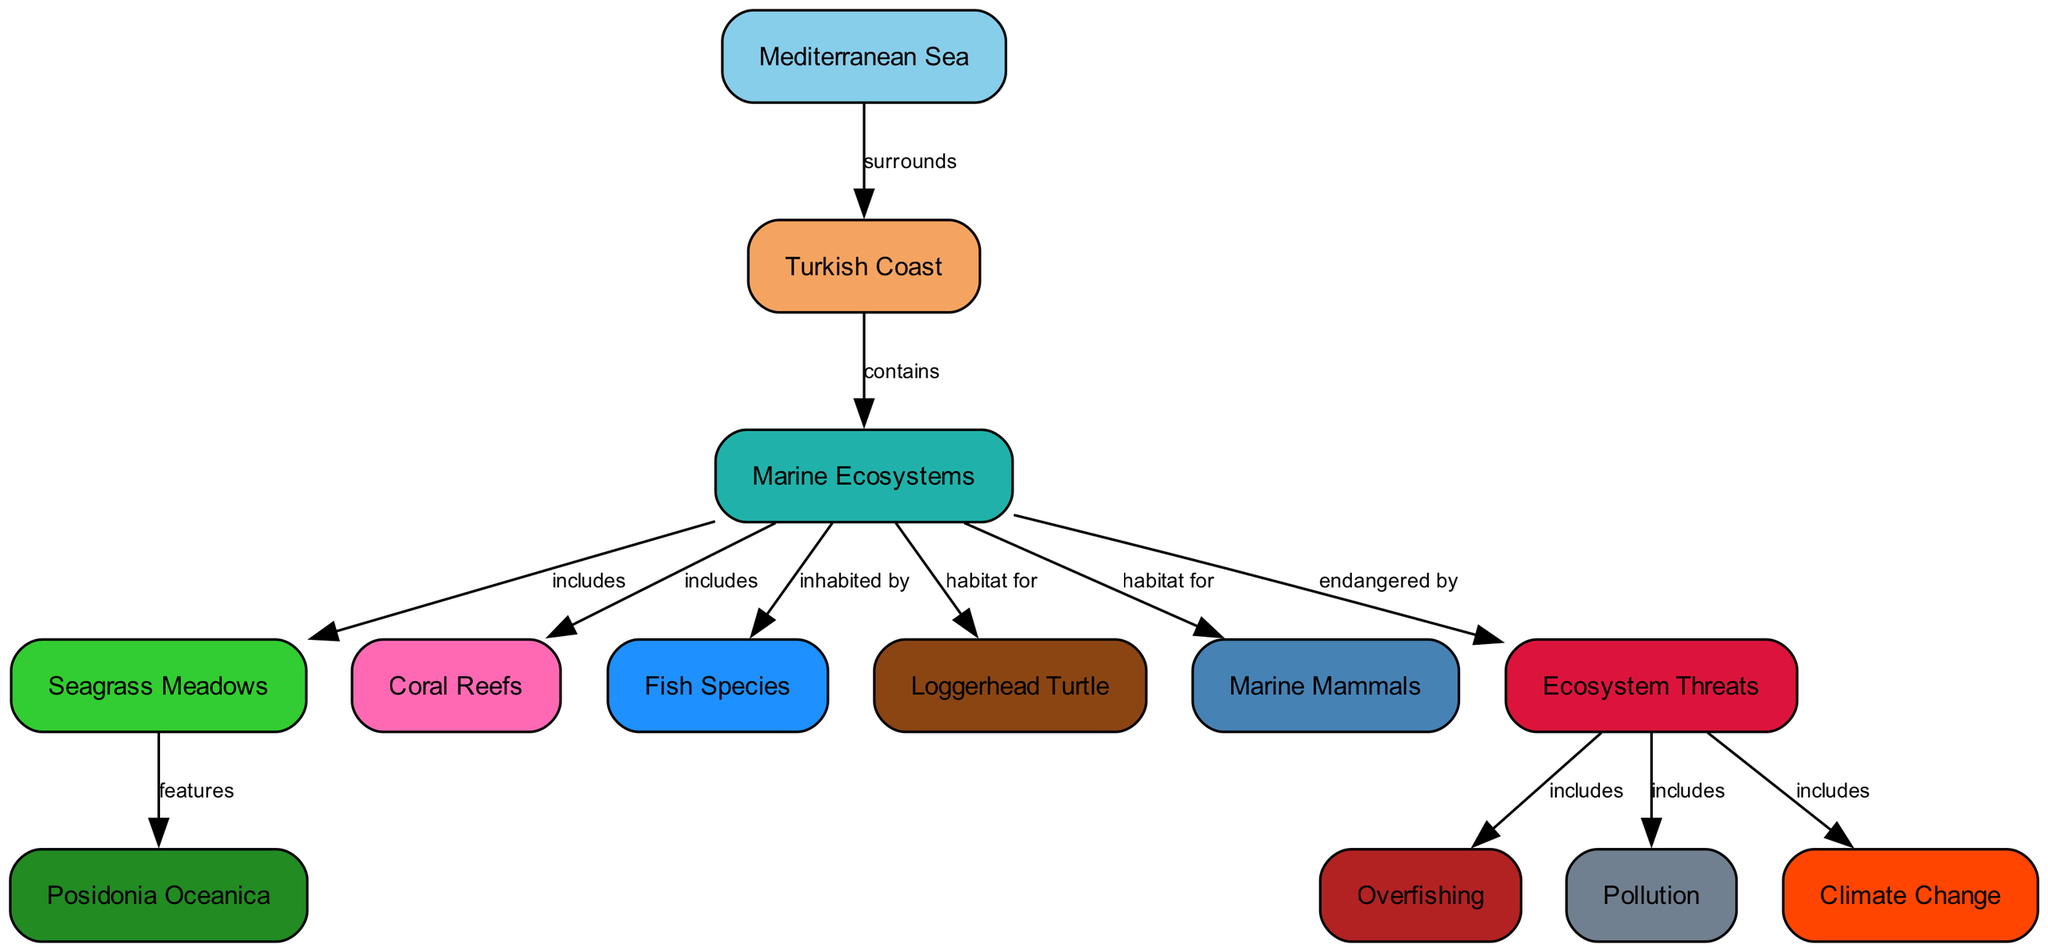What does the Mediterranean Sea surround? The diagram connects the Mediterranean Sea to the Turkish Coast with an edge labeled "surrounds." This indicates that the sea encircles this specific coastal region.
Answer: Turkish Coast What habitats are included in the Marine Ecosystems? The diagram shows that Marine Ecosystems include Seagrass Meadows and Coral Reefs, as indicated by the edges labeled "includes." This demonstrates that these ecosystems are parts of the broader marine environment.
Answer: Seagrass Meadows, Coral Reefs How many threats to the ecosystem are listed? The diagram identifies three threats: Overfishing, Pollution, and Climate Change, as per the edges leading from Ecosystem Threats. This means a total of three distinct threats are mentioned.
Answer: 3 What species of seagrass is featured? The diagram indicates that Posidonia Oceanica is specifically highlighted as a feature of the Seagrass Meadows, using the "features" edge from Seagrass Meadows to Posidonia Oceanica.
Answer: Posidonia Oceanica Which species is a habitat for Marine Mammals? The diagram shows that Marine Ecosystems provide habitat for Marine Mammals as indicated by the edge connecting these two nodes with the label "habitat for." This implies that marine mammals inhabit these ecosystems.
Answer: Marine Ecosystems What type of ecosystem is mentioned to be endangered? The diagram states that Marine Ecosystems are endangered by Ecosystem Threats, as shown by the labeled edge. This indicates that the health of marine ecosystems is compromised due to various threats.
Answer: Marine Ecosystems Identify one species of fish inhabiting the Mediterranean Sea. The diagram specifies that Marine Ecosystems are inhabited by Fish Species, but does not provide specific names. However, it emphasizes that various fish species live in this environment.
Answer: Fish Species What type of pollution affects the Mediterranean Sea? The diagram indicates that Pollution, linked to human activities, is one of the Ecosystem Threats. This highlights the detrimental impact of contaminants from various sources on the marine environment.
Answer: Pollution How do human activities impact the ecosystem? The diagram illustrates that human activities contribute to Ecosystem Threats, including Overfishing, Pollution, and Climate Change. This connection emphasizes the negative effects of such actions on marine habitats.
Answer: Ecosystem Threats 